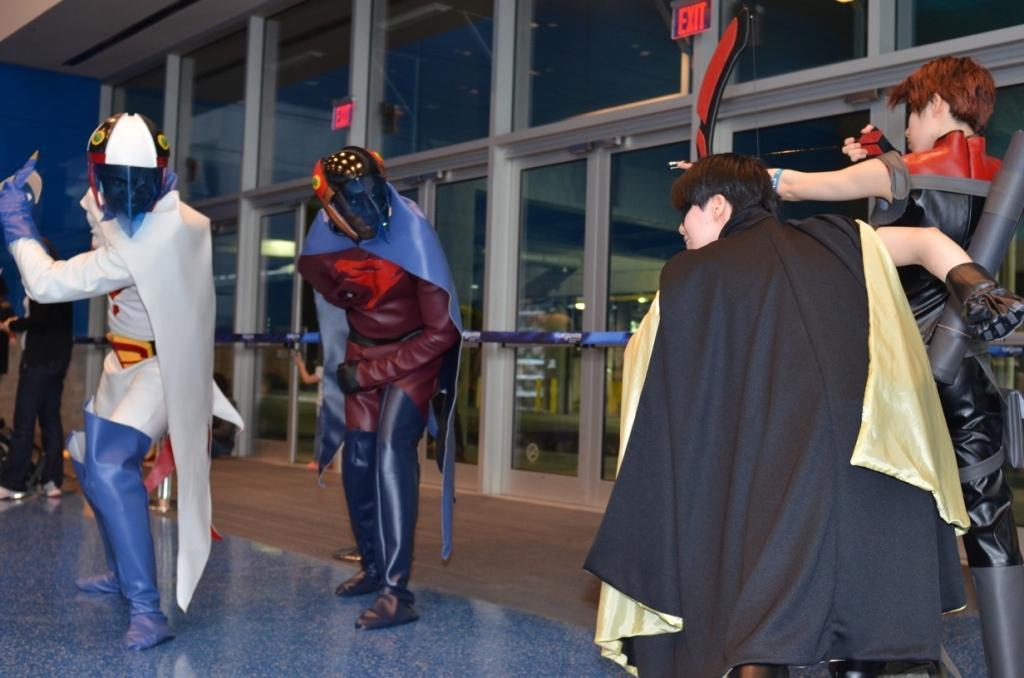Could you give a brief overview of what you see in this image? In this image I can see few people are standing and I can see all of them are wearing costumes. I can see few glass doors and few red colour exit sign boards. I can also see few more people in background. 